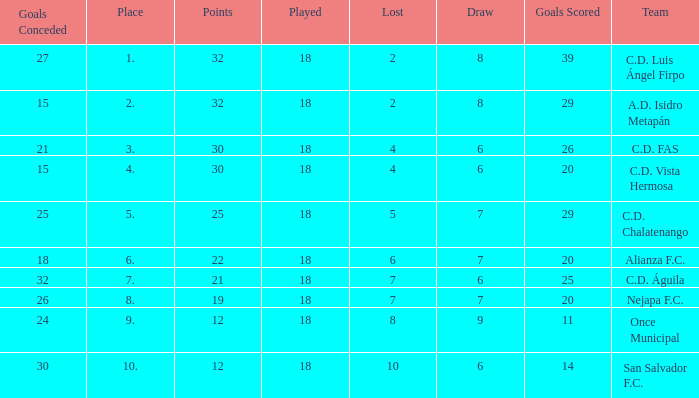What is the total number for a place with points smaller than 12? 0.0. 